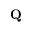Convert formula to latex. <formula><loc_0><loc_0><loc_500><loc_500>Q</formula> 